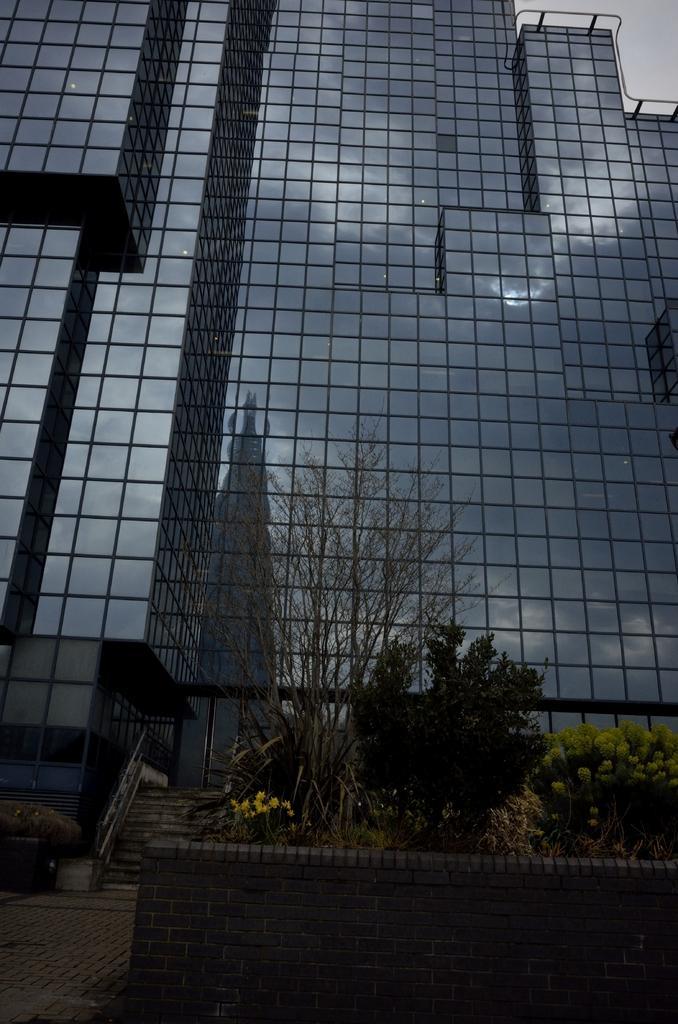In one or two sentences, can you explain what this image depicts? In this image in the front there is a wall and on the top of the wall there are plants. In the background there is a building and there is a staircase. 